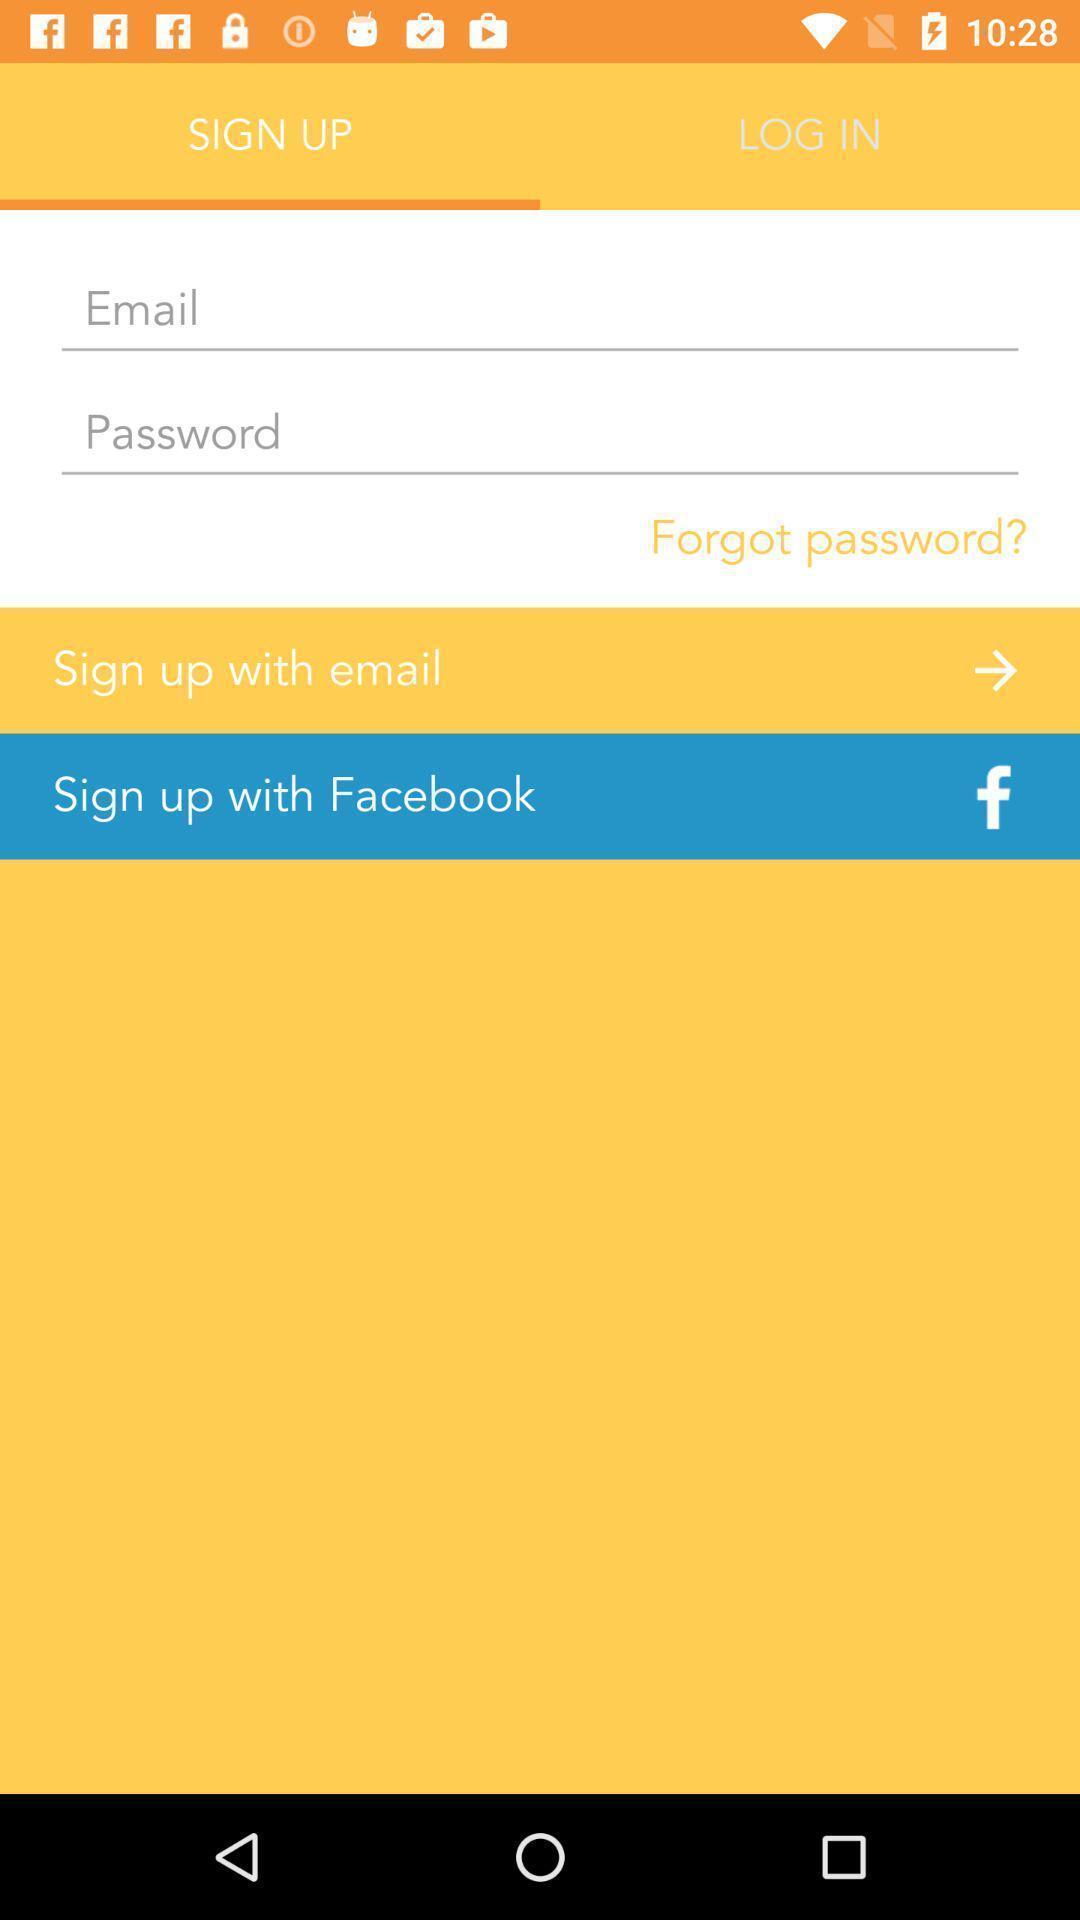Describe the key features of this screenshot. Sign-up page for a monitoring app. 